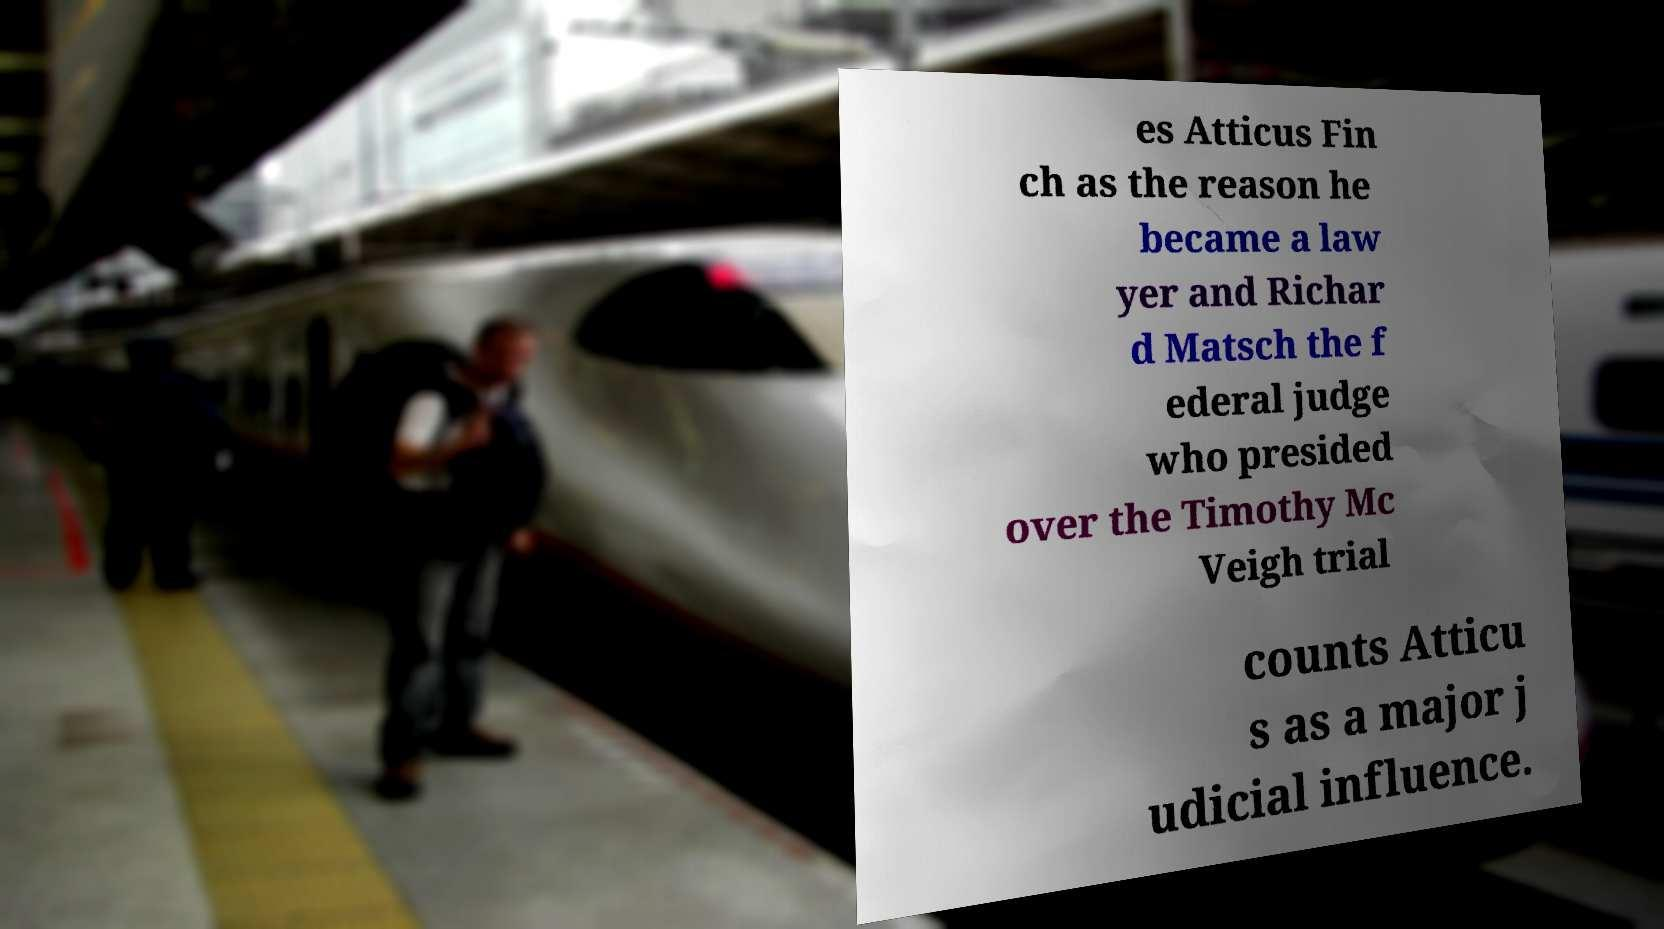Could you assist in decoding the text presented in this image and type it out clearly? es Atticus Fin ch as the reason he became a law yer and Richar d Matsch the f ederal judge who presided over the Timothy Mc Veigh trial counts Atticu s as a major j udicial influence. 